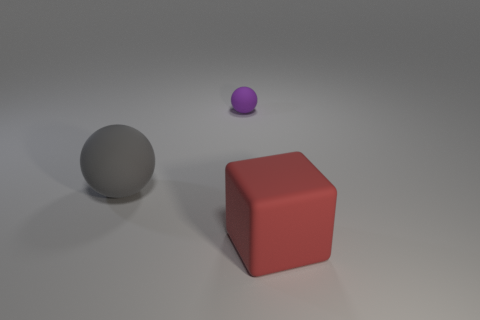Add 3 cubes. How many objects exist? 6 Subtract all spheres. How many objects are left? 1 Add 1 large cyan things. How many large cyan things exist? 1 Subtract 0 brown cylinders. How many objects are left? 3 Subtract all small blue matte cylinders. Subtract all large matte blocks. How many objects are left? 2 Add 1 purple spheres. How many purple spheres are left? 2 